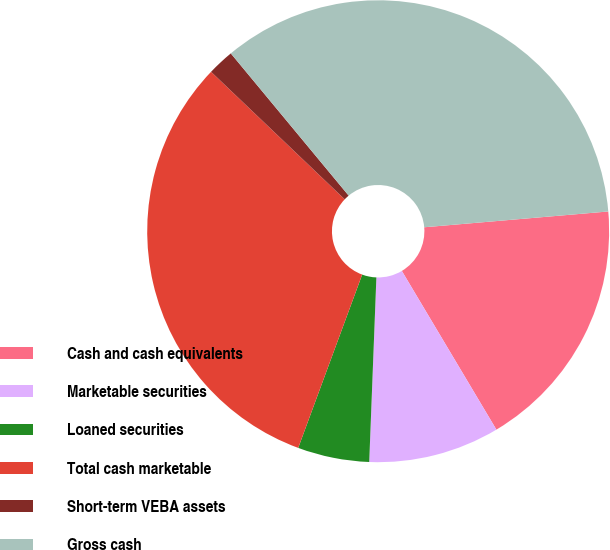<chart> <loc_0><loc_0><loc_500><loc_500><pie_chart><fcel>Cash and cash equivalents<fcel>Marketable securities<fcel>Loaned securities<fcel>Total cash marketable<fcel>Short-term VEBA assets<fcel>Gross cash<nl><fcel>17.81%<fcel>9.17%<fcel>5.01%<fcel>31.5%<fcel>1.86%<fcel>34.65%<nl></chart> 